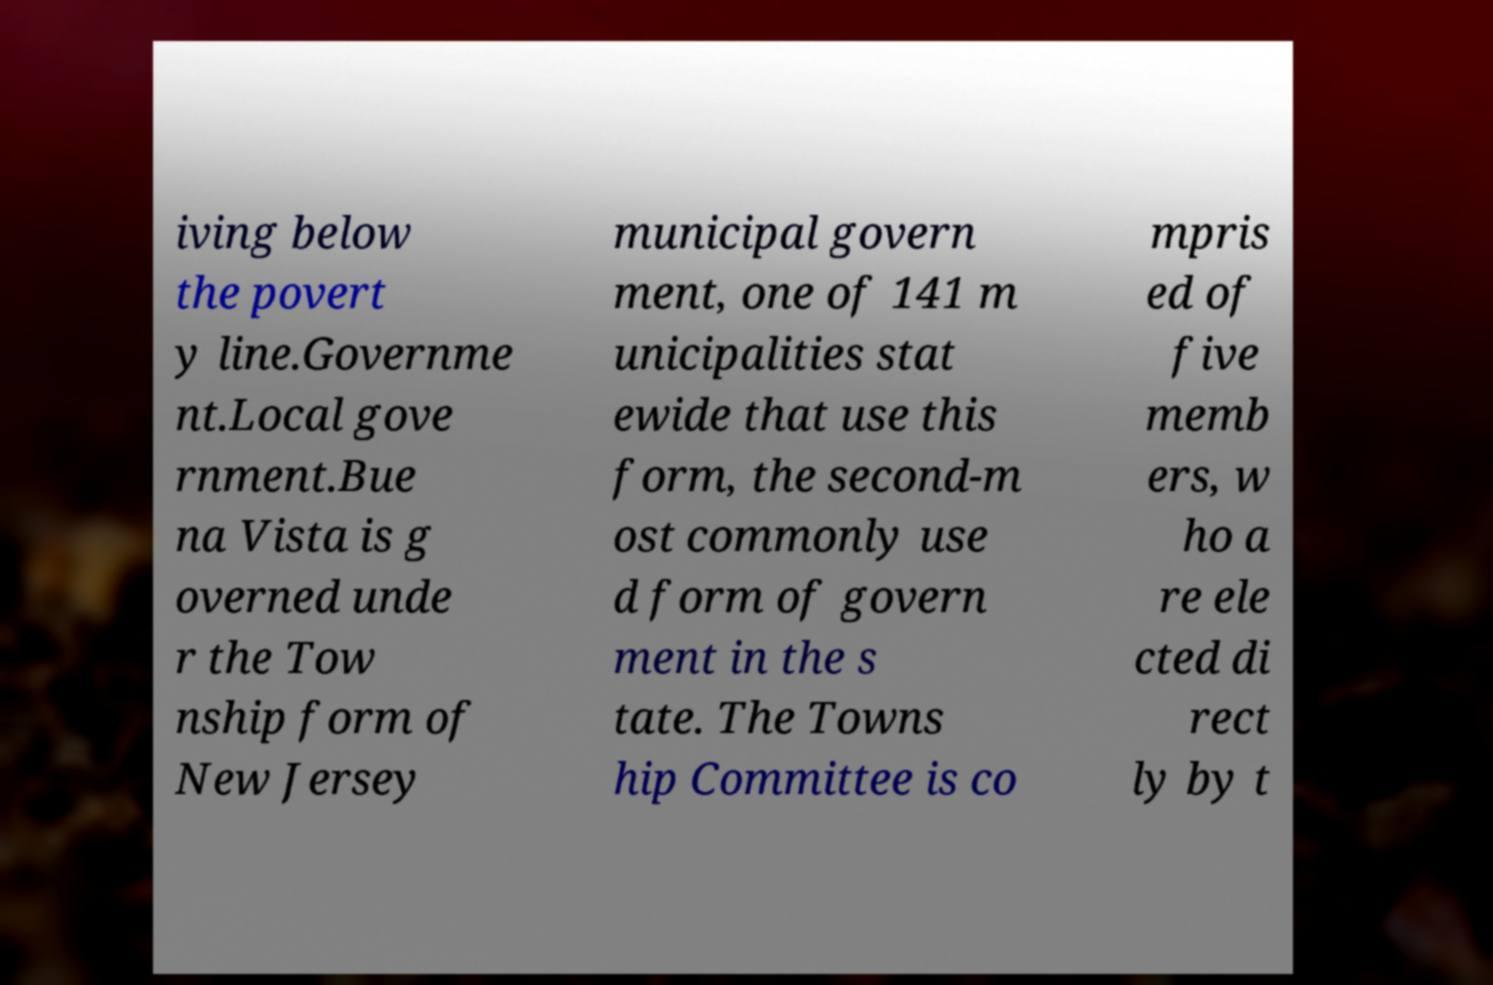Can you read and provide the text displayed in the image?This photo seems to have some interesting text. Can you extract and type it out for me? iving below the povert y line.Governme nt.Local gove rnment.Bue na Vista is g overned unde r the Tow nship form of New Jersey municipal govern ment, one of 141 m unicipalities stat ewide that use this form, the second-m ost commonly use d form of govern ment in the s tate. The Towns hip Committee is co mpris ed of five memb ers, w ho a re ele cted di rect ly by t 